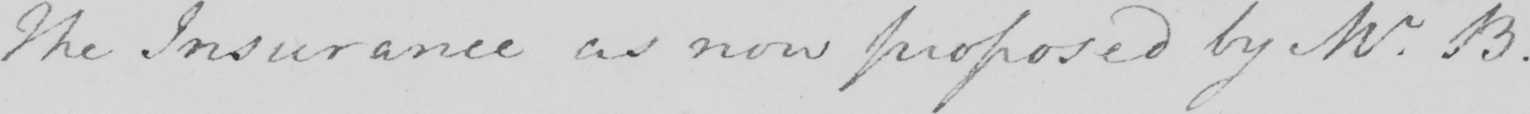What is written in this line of handwriting? The Insurance as now proposed by Mr . B . 